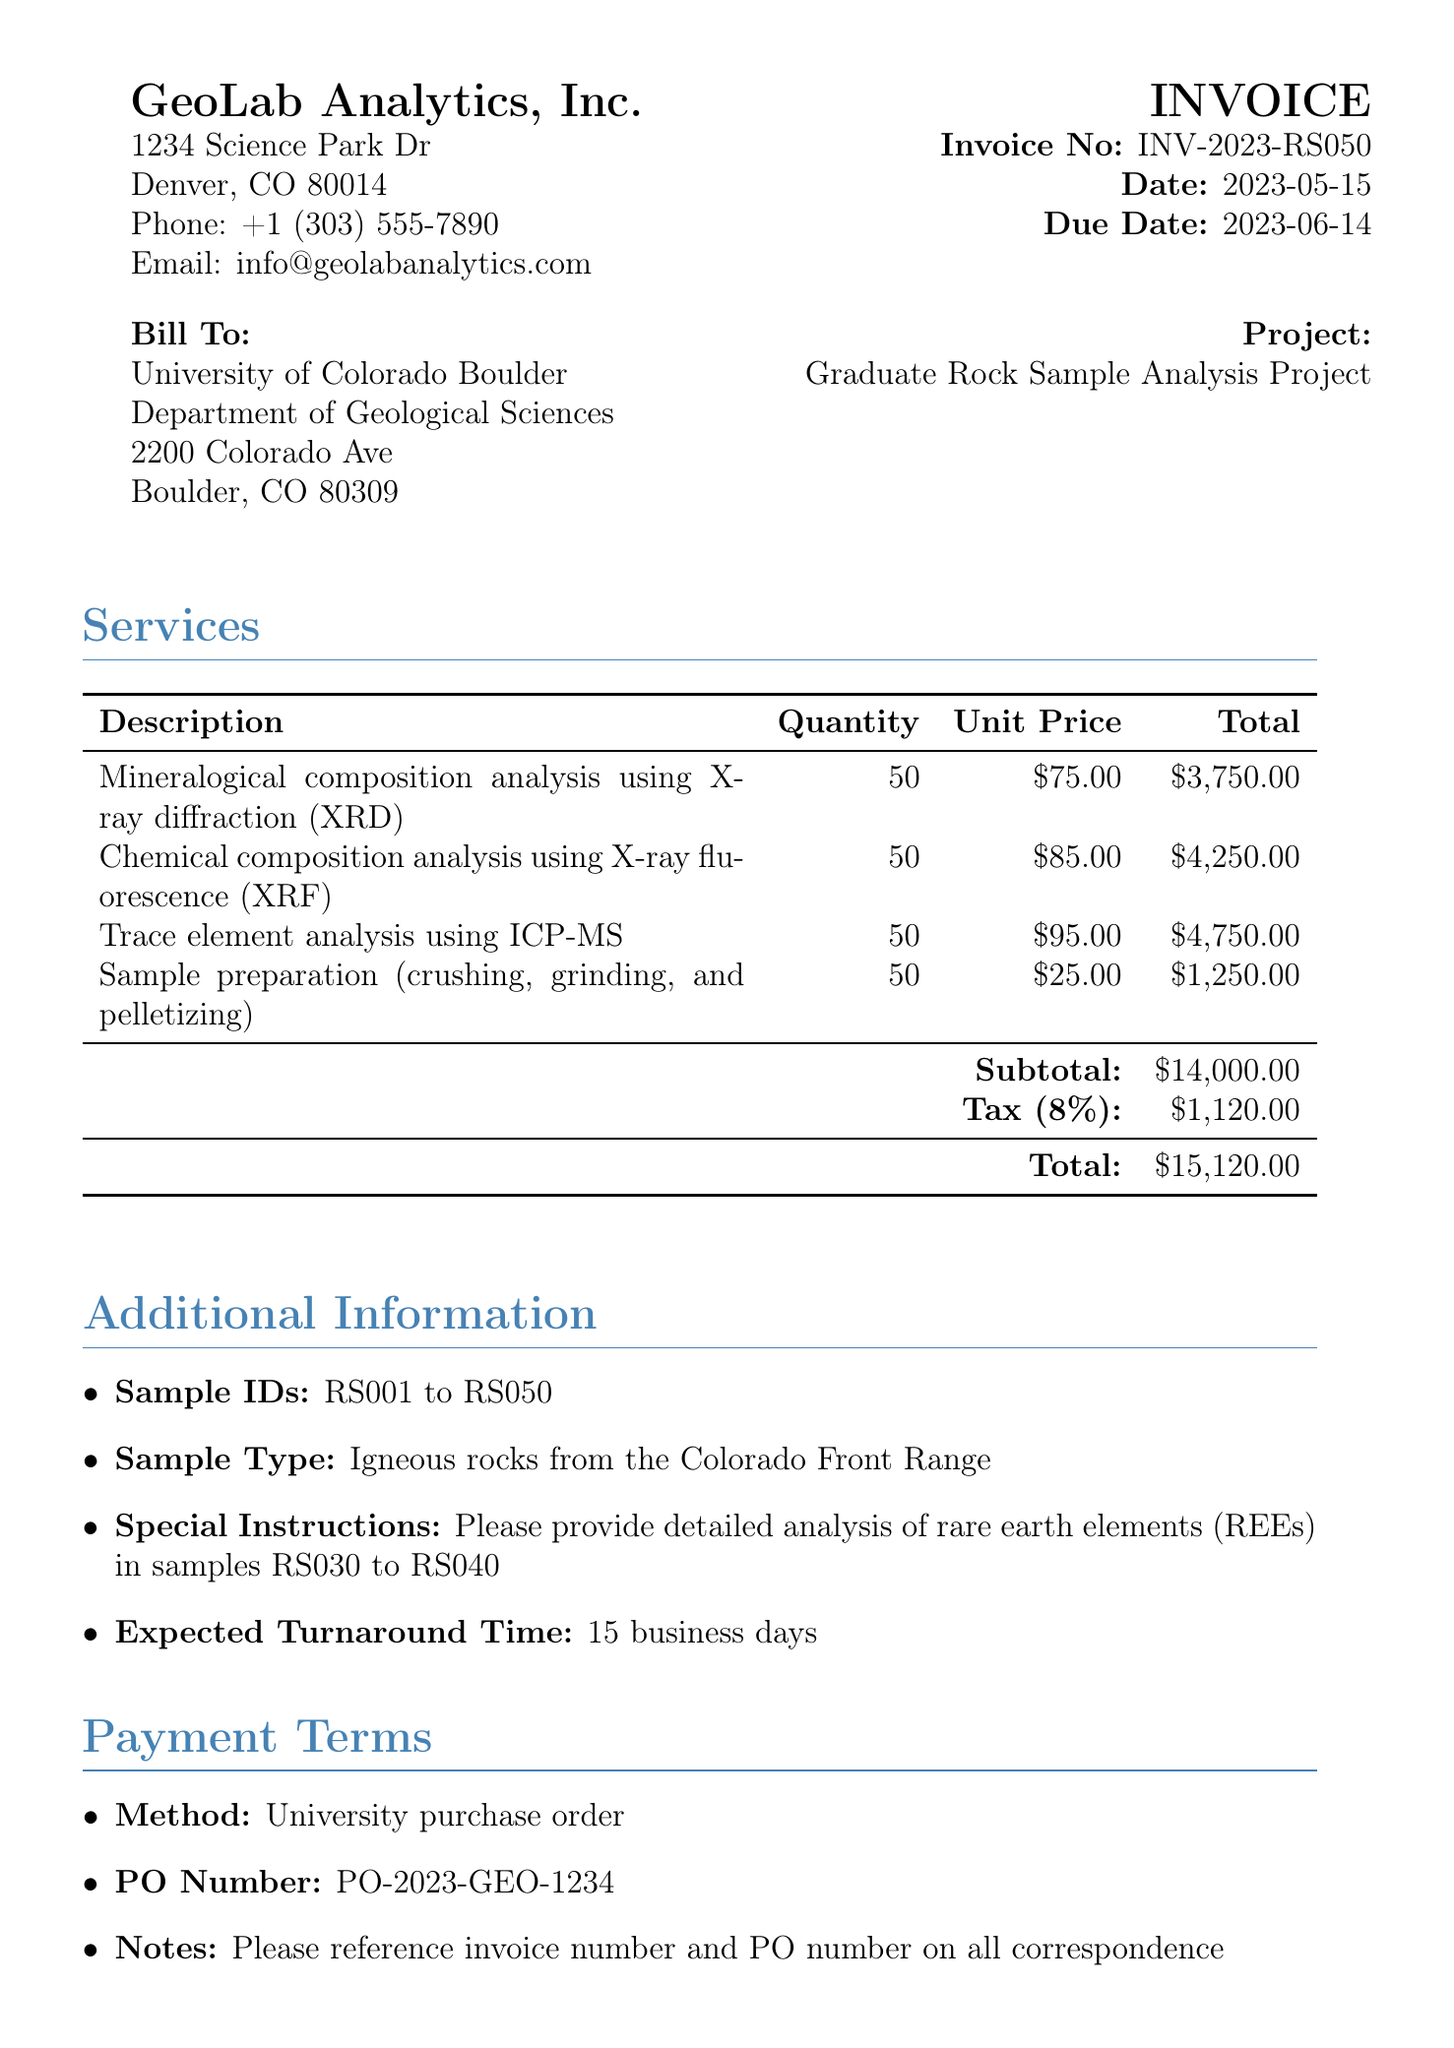What is the invoice number? The invoice number is clearly listed in the document under invoice details.
Answer: INV-2023-RS050 What is the total amount due? The total amount due can be found at the bottom of the services section.
Answer: $15,120.00 Who is the service provider? The name of the service provider is stated at the top of the document.
Answer: GeoLab Analytics, Inc What is the due date for payment? The due date is mentioned along with the invoice date in the invoice details.
Answer: 2023-06-14 How many samples are being analyzed? The quantity of samples is indicated in the services section for each type of analysis.
Answer: 50 What is the tax rate applied? The tax rate can be located next to the tax amount in the subtotal section.
Answer: 8% What method of payment is specified? The payment terms specify the method of payment in the document.
Answer: University purchase order What special analysis is requested in the instructions? The special instructions section describes additional analysis required for specific samples.
Answer: Detailed analysis of rare earth elements What is the expected turnaround time for results? The expected turnaround time is specified clearly in the additional information section.
Answer: 15 business days 